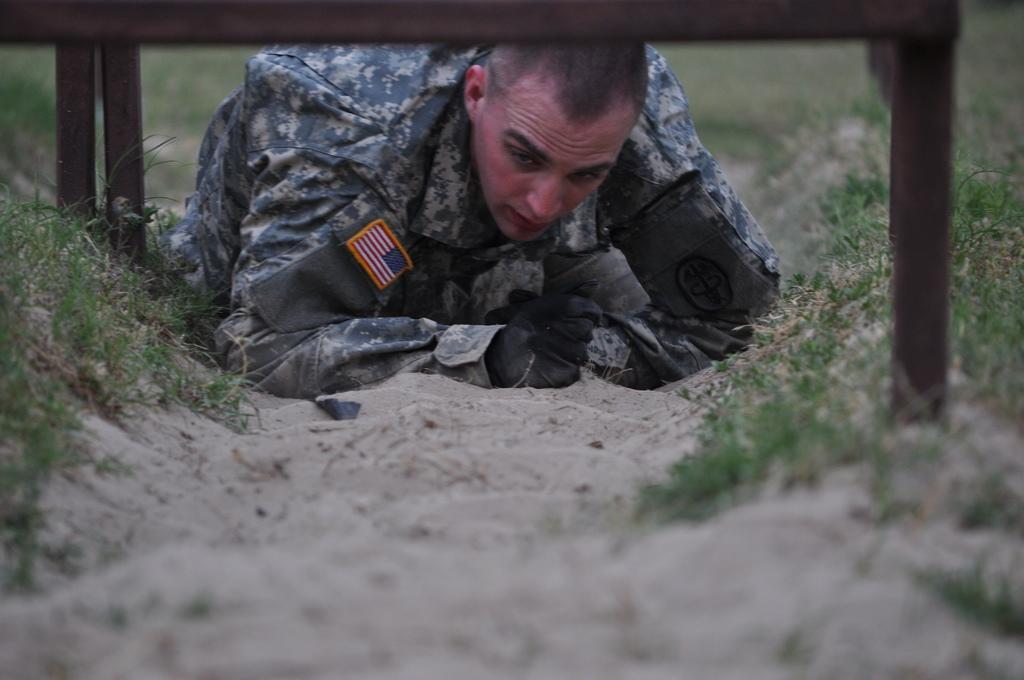In one or two sentences, can you explain what this image depicts? In this picture we can see a person on the ground, here we can see rods, grass and in the background we can see it is blurry. 